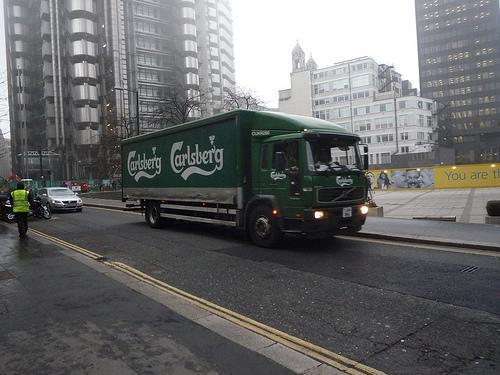How many times is the word Carlsberg shown?
Give a very brief answer. 2. How many different types of vehicles are pictured?
Give a very brief answer. 3. 